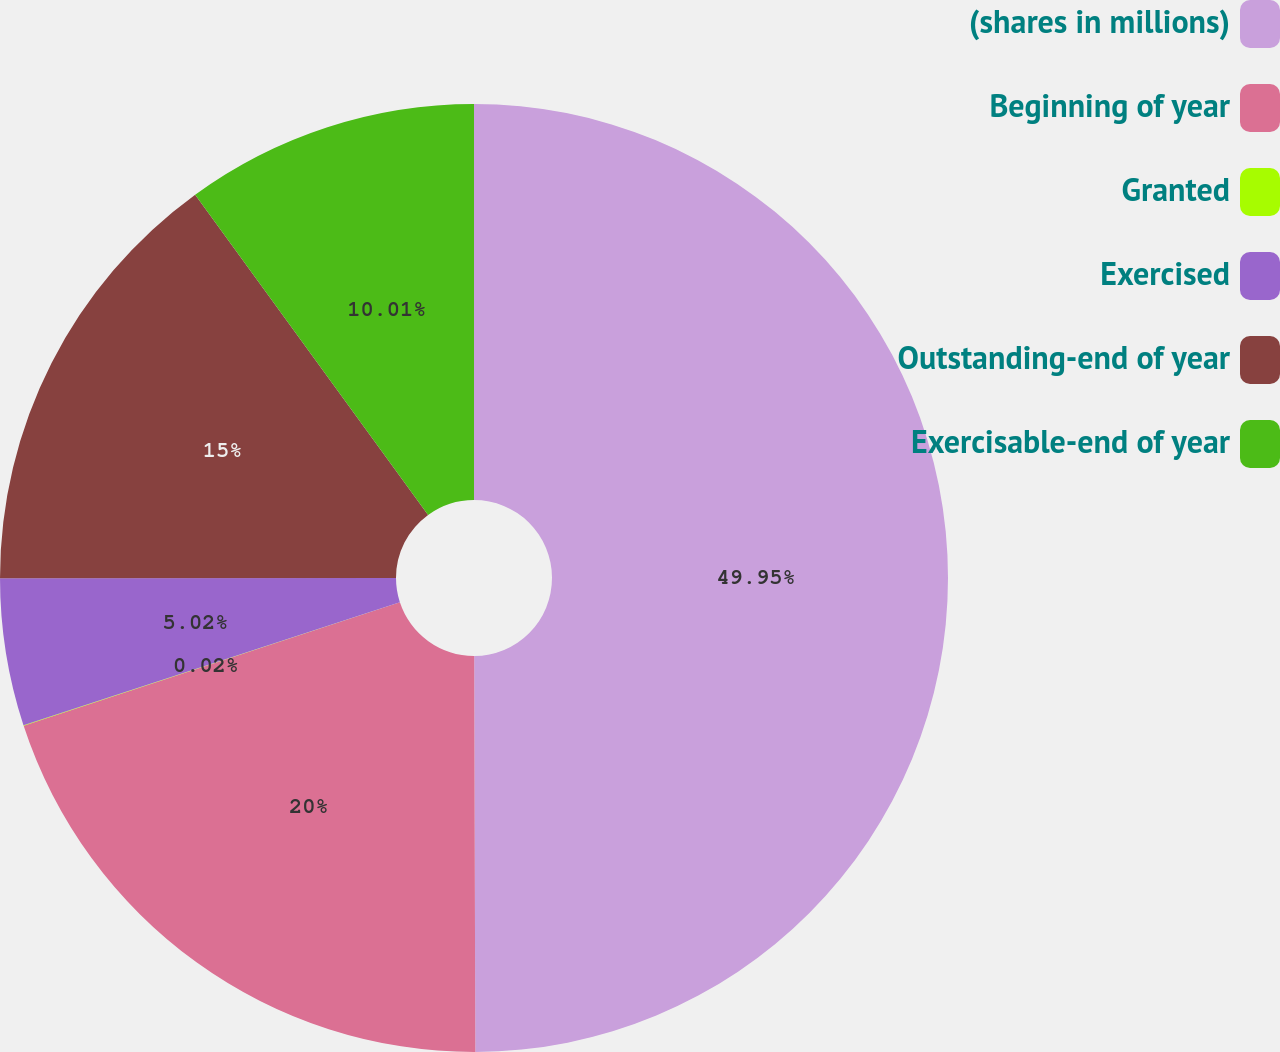<chart> <loc_0><loc_0><loc_500><loc_500><pie_chart><fcel>(shares in millions)<fcel>Beginning of year<fcel>Granted<fcel>Exercised<fcel>Outstanding-end of year<fcel>Exercisable-end of year<nl><fcel>49.96%<fcel>20.0%<fcel>0.02%<fcel>5.02%<fcel>15.0%<fcel>10.01%<nl></chart> 